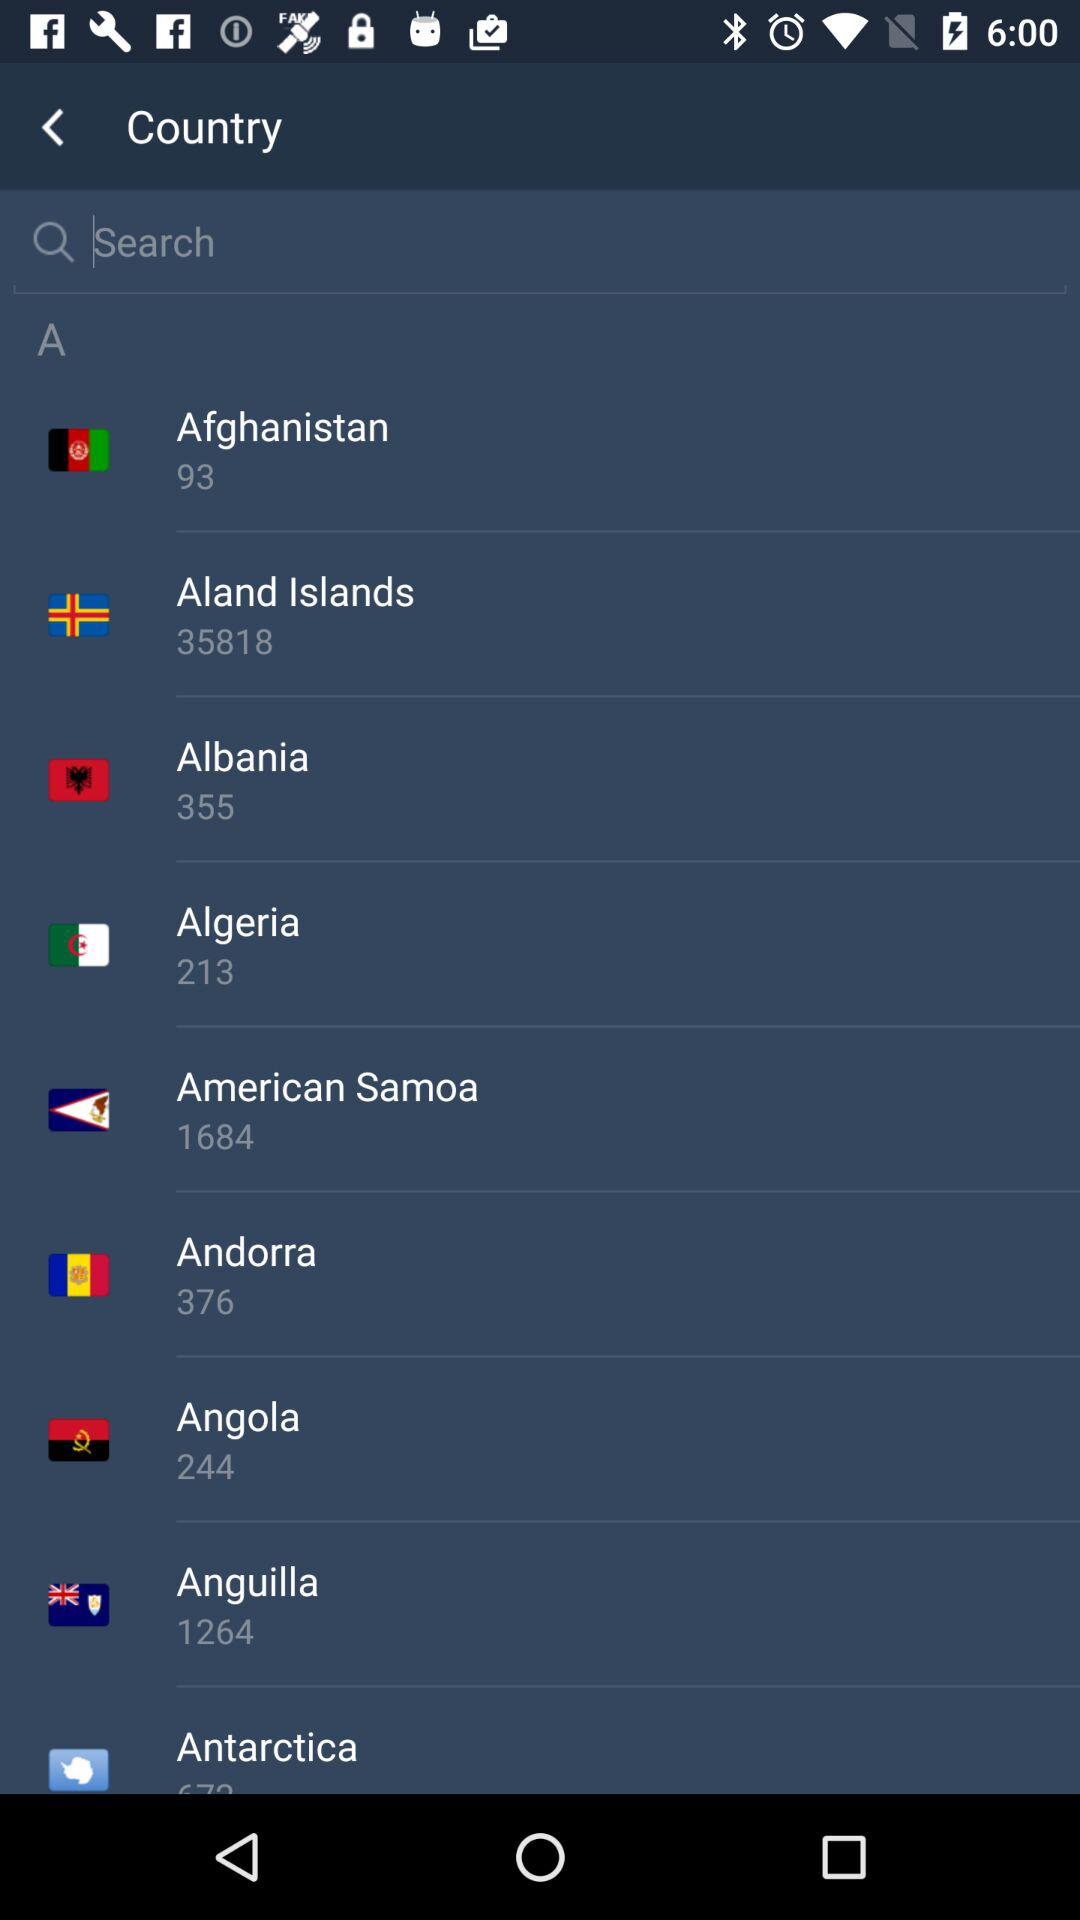What is the country code of Algeria? The country code of Algeria is 213. 